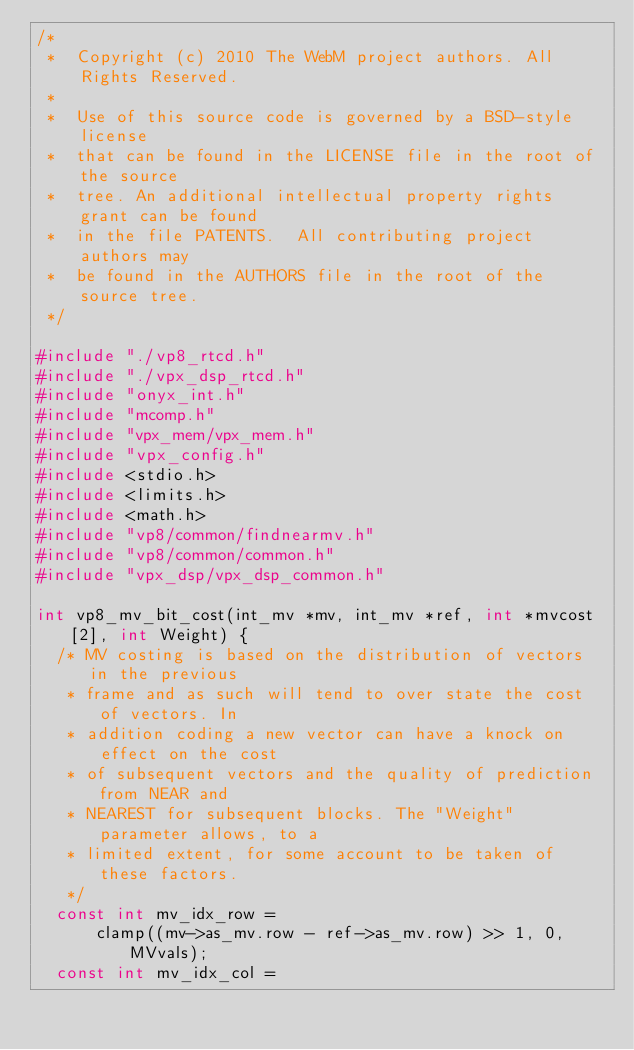Convert code to text. <code><loc_0><loc_0><loc_500><loc_500><_C_>/*
 *  Copyright (c) 2010 The WebM project authors. All Rights Reserved.
 *
 *  Use of this source code is governed by a BSD-style license
 *  that can be found in the LICENSE file in the root of the source
 *  tree. An additional intellectual property rights grant can be found
 *  in the file PATENTS.  All contributing project authors may
 *  be found in the AUTHORS file in the root of the source tree.
 */

#include "./vp8_rtcd.h"
#include "./vpx_dsp_rtcd.h"
#include "onyx_int.h"
#include "mcomp.h"
#include "vpx_mem/vpx_mem.h"
#include "vpx_config.h"
#include <stdio.h>
#include <limits.h>
#include <math.h>
#include "vp8/common/findnearmv.h"
#include "vp8/common/common.h"
#include "vpx_dsp/vpx_dsp_common.h"

int vp8_mv_bit_cost(int_mv *mv, int_mv *ref, int *mvcost[2], int Weight) {
  /* MV costing is based on the distribution of vectors in the previous
   * frame and as such will tend to over state the cost of vectors. In
   * addition coding a new vector can have a knock on effect on the cost
   * of subsequent vectors and the quality of prediction from NEAR and
   * NEAREST for subsequent blocks. The "Weight" parameter allows, to a
   * limited extent, for some account to be taken of these factors.
   */
  const int mv_idx_row =
      clamp((mv->as_mv.row - ref->as_mv.row) >> 1, 0, MVvals);
  const int mv_idx_col =</code> 